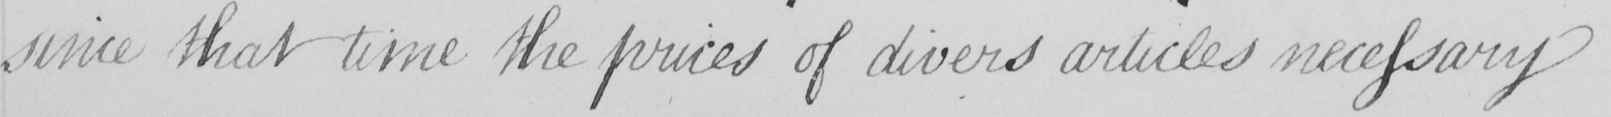Can you tell me what this handwritten text says? since that time the prices of divers articles necessary 